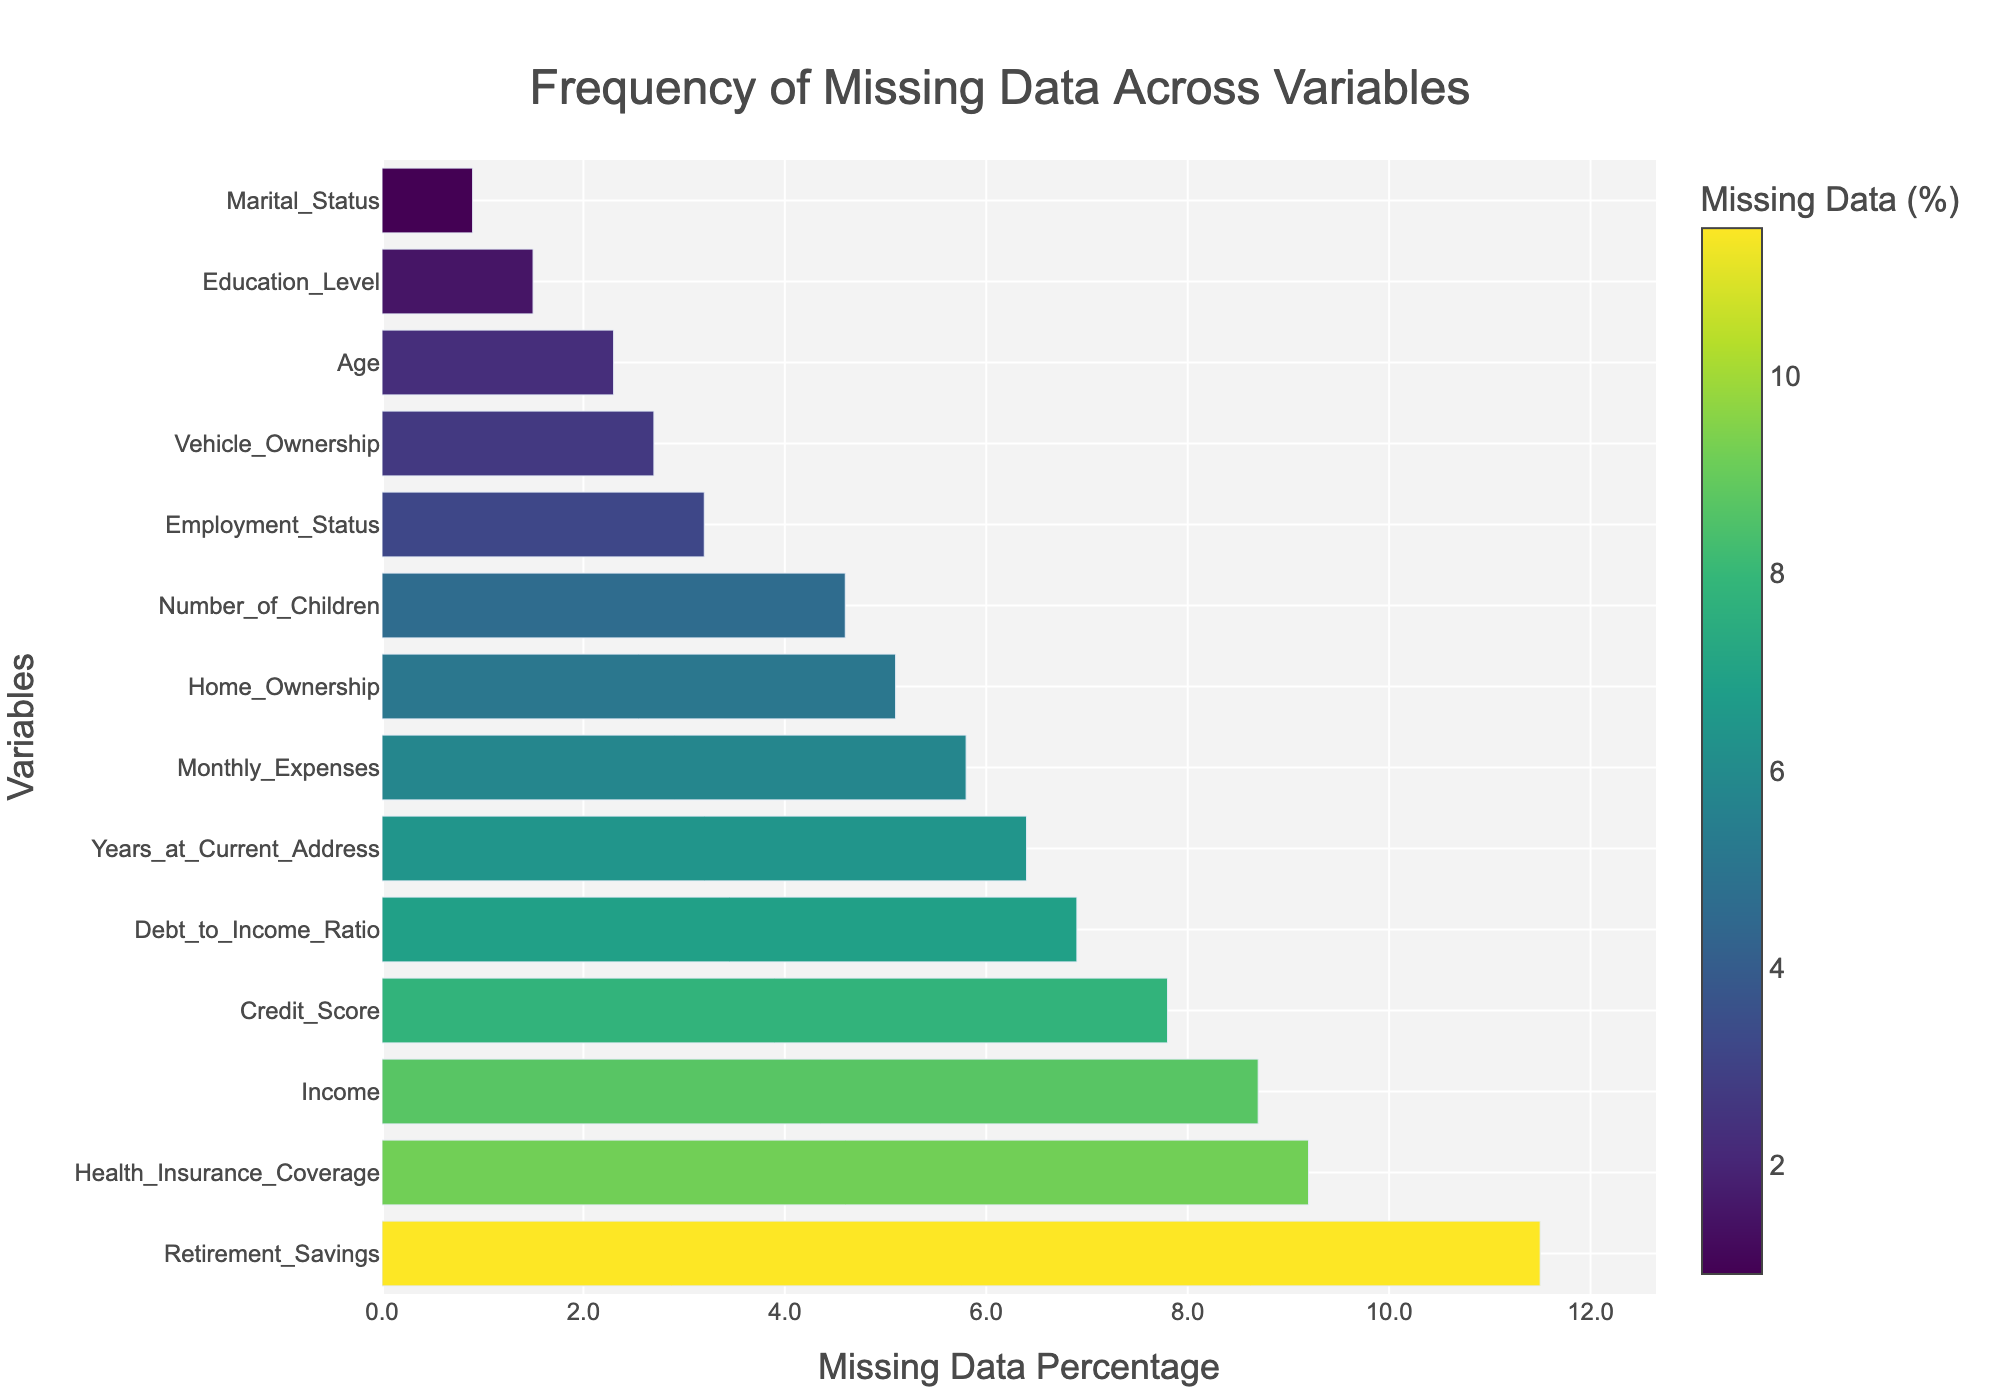How many variables have more than 5% missing data? To find this, identify the bars that extend beyond the 5% mark on the x-axis. These variables are: Income, Credit Score, Years at Current Address, Health Insurance Coverage, Retirement Savings, Debt to Income Ratio, and Monthly Expenses. There are 7 such variables.
Answer: 7 Which variable has the most missing data? The variable with the highest missing data percentage is located at the top of the sorted histogram. This variable is Retirement Savings with 11.5%.
Answer: Retirement Savings How much higher is the missing data percentage for Retirement Savings compared to Marital Status? Locate the bars for both Retirement Savings and Marital Status. Retirement Savings has 11.5% missing data and Marital Status has 0.9%. The difference is 11.5% - 0.9% = 10.6%.
Answer: 10.6% What is the mean percentage of missing data for the variables? To find the mean percentage, sum all the percentages and divide by the number of variables. The percentages are: 2.3, 8.7, 1.5, 3.2, 0.9, 4.6, 5.1, 7.8, 6.4, 2.7, 9.2, 11.5, 6.9, 5.8. Summing these gives 76.6. Dividing by the 14 variables results in an average of 76.6/14 ≈ 5.47%.
Answer: ~5.47% Which variables have less than 3% missing data? Identify the bars that extend up to the 3% mark on the x-axis. These variables are: Age, Education Level, Employment Status, Marital Status, and Vehicle Ownership.
Answer: Age, Education Level, Employment Status, Marital Status, Vehicle Ownership Which variable has the second-highest percentage of missing data? Locate the first and second bars from the top of the sorted histogram. The second bar represents Health Insurance Coverage with 9.2%.
Answer: Health Insurance Coverage How does the missing data for Income compare to that for Debt to Income Ratio? Compare the lengths of the bars for Income and Debt to Income Ratio. Income has 8.7% missing data, while Debt to Income Ratio has 6.9%. Income has a higher percentage of missing data by 1.8%.
Answer: Income; 1.8% higher What is the range of the missing data percentages across all variables? To calculate the range, subtract the smallest percentage from the largest. The largest missing data percentage is for Retirement Savings (11.5%) and the smallest is for Marital Status (0.9%). The range is 11.5% - 0.9% = 10.6%.
Answer: 10.6% 